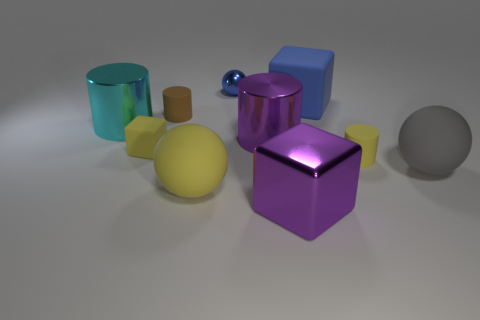Are there any brown cylinders that have the same size as the blue metallic ball?
Your response must be concise. Yes. What is the material of the yellow cylinder that is the same size as the brown cylinder?
Your response must be concise. Rubber. There is a cube that is on the right side of the purple metal block; does it have the same size as the yellow rubber thing to the right of the tiny sphere?
Make the answer very short. No. What number of things are big blue spheres or big shiny objects on the left side of the purple metal cylinder?
Provide a succinct answer. 1. Are there any gray matte objects of the same shape as the small shiny object?
Offer a terse response. Yes. How big is the rubber cylinder that is to the right of the large ball that is in front of the gray rubber thing?
Ensure brevity in your answer.  Small. Do the big rubber block and the tiny shiny ball have the same color?
Keep it short and to the point. Yes. What number of matte objects are either yellow cylinders or yellow things?
Keep it short and to the point. 3. How many large purple balls are there?
Provide a succinct answer. 0. Does the purple object to the left of the big purple metallic cube have the same material as the tiny thing behind the brown rubber thing?
Ensure brevity in your answer.  Yes. 